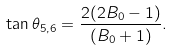Convert formula to latex. <formula><loc_0><loc_0><loc_500><loc_500>\tan \theta _ { 5 , 6 } = \frac { 2 ( 2 B _ { 0 } - 1 ) } { ( B _ { 0 } + 1 ) } .</formula> 